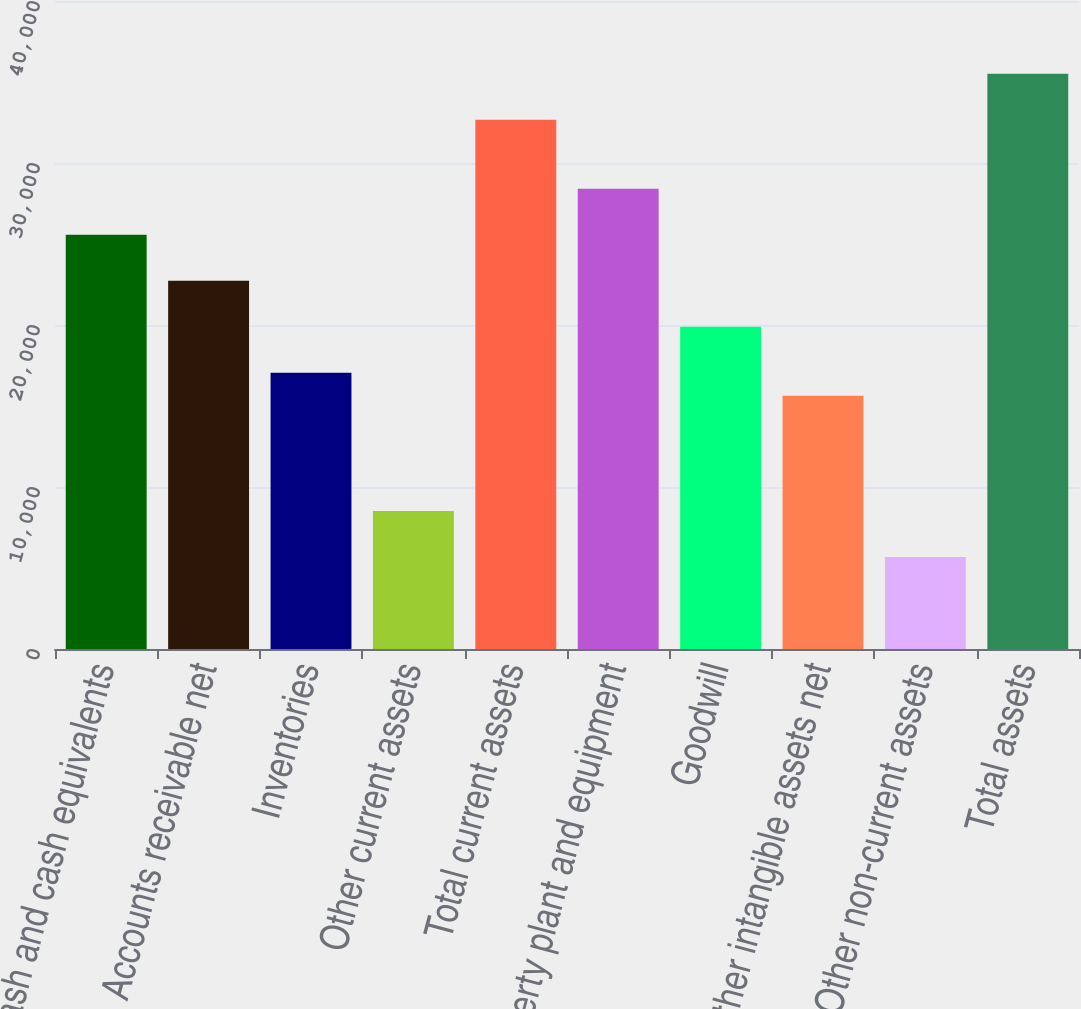Convert chart. <chart><loc_0><loc_0><loc_500><loc_500><bar_chart><fcel>Cash and cash equivalents<fcel>Accounts receivable net<fcel>Inventories<fcel>Other current assets<fcel>Total current assets<fcel>Property plant and equipment<fcel>Goodwill<fcel>Other intangible assets net<fcel>Other non-current assets<fcel>Total assets<nl><fcel>25568.4<fcel>22727.8<fcel>17046.6<fcel>8524.8<fcel>32669.9<fcel>28409<fcel>19887.2<fcel>15626.3<fcel>5684.2<fcel>35510.5<nl></chart> 